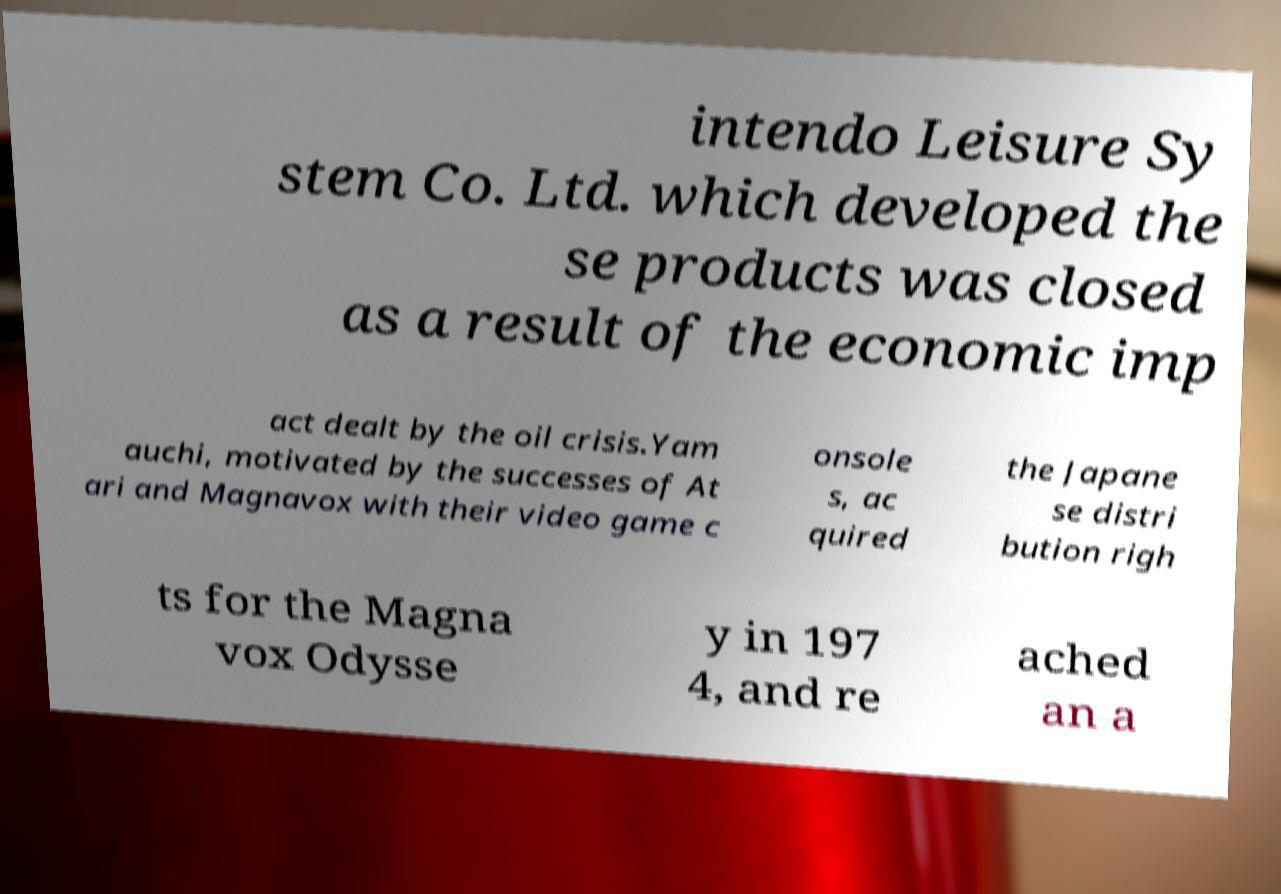Can you accurately transcribe the text from the provided image for me? intendo Leisure Sy stem Co. Ltd. which developed the se products was closed as a result of the economic imp act dealt by the oil crisis.Yam auchi, motivated by the successes of At ari and Magnavox with their video game c onsole s, ac quired the Japane se distri bution righ ts for the Magna vox Odysse y in 197 4, and re ached an a 